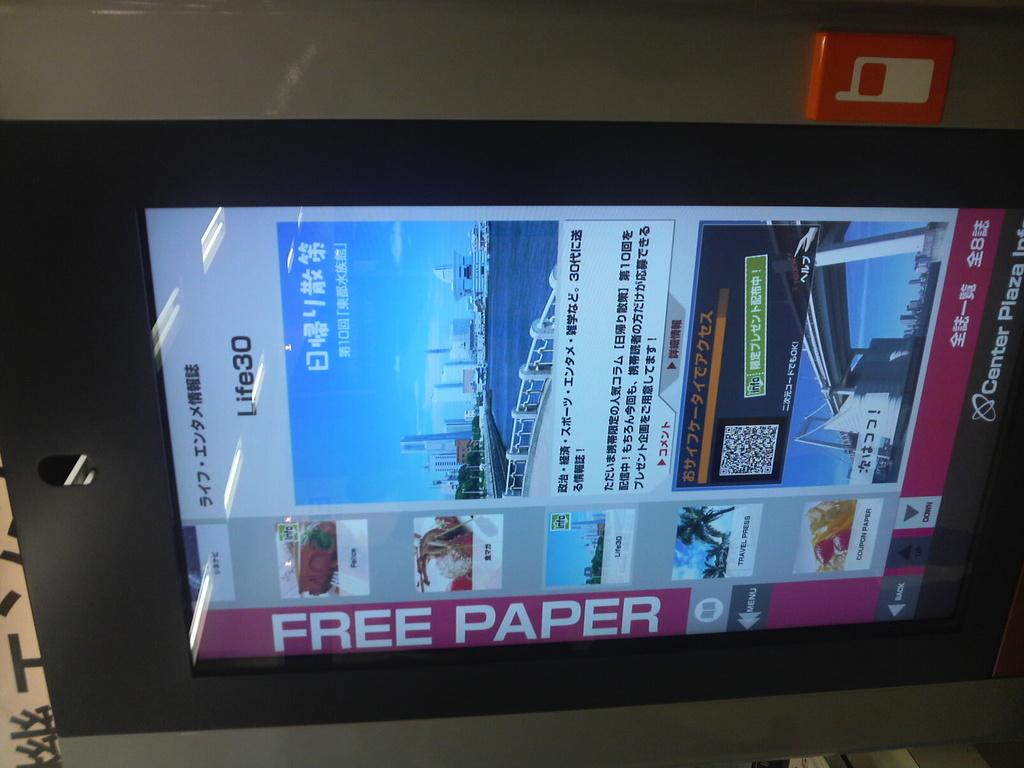What is the main object in the image? There is a screen in the image. What can be seen behind the screen? There is a wall behind the screen. Is there anything on the wall in the image? Yes, there is an object on the wall. How does the deer interact with the object on the wall in the image? There is no deer present in the image, so it cannot interact with the object on the wall. 